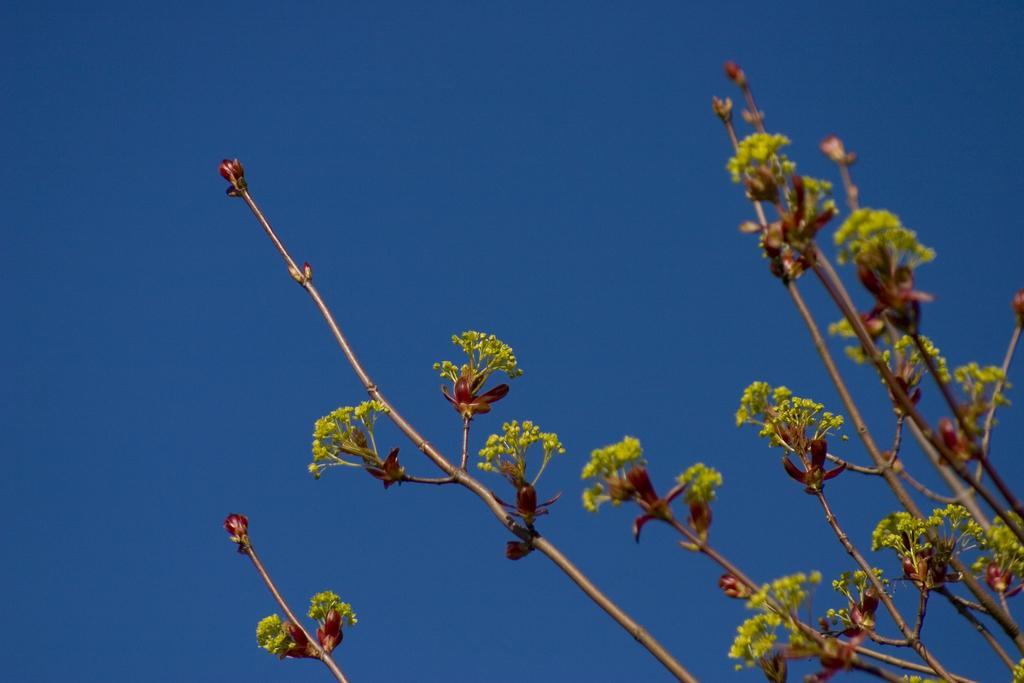Could you give a brief overview of what you see in this image? The picture consists of stems of a tree, there are flowers. Sky is clear and it is sunny. 